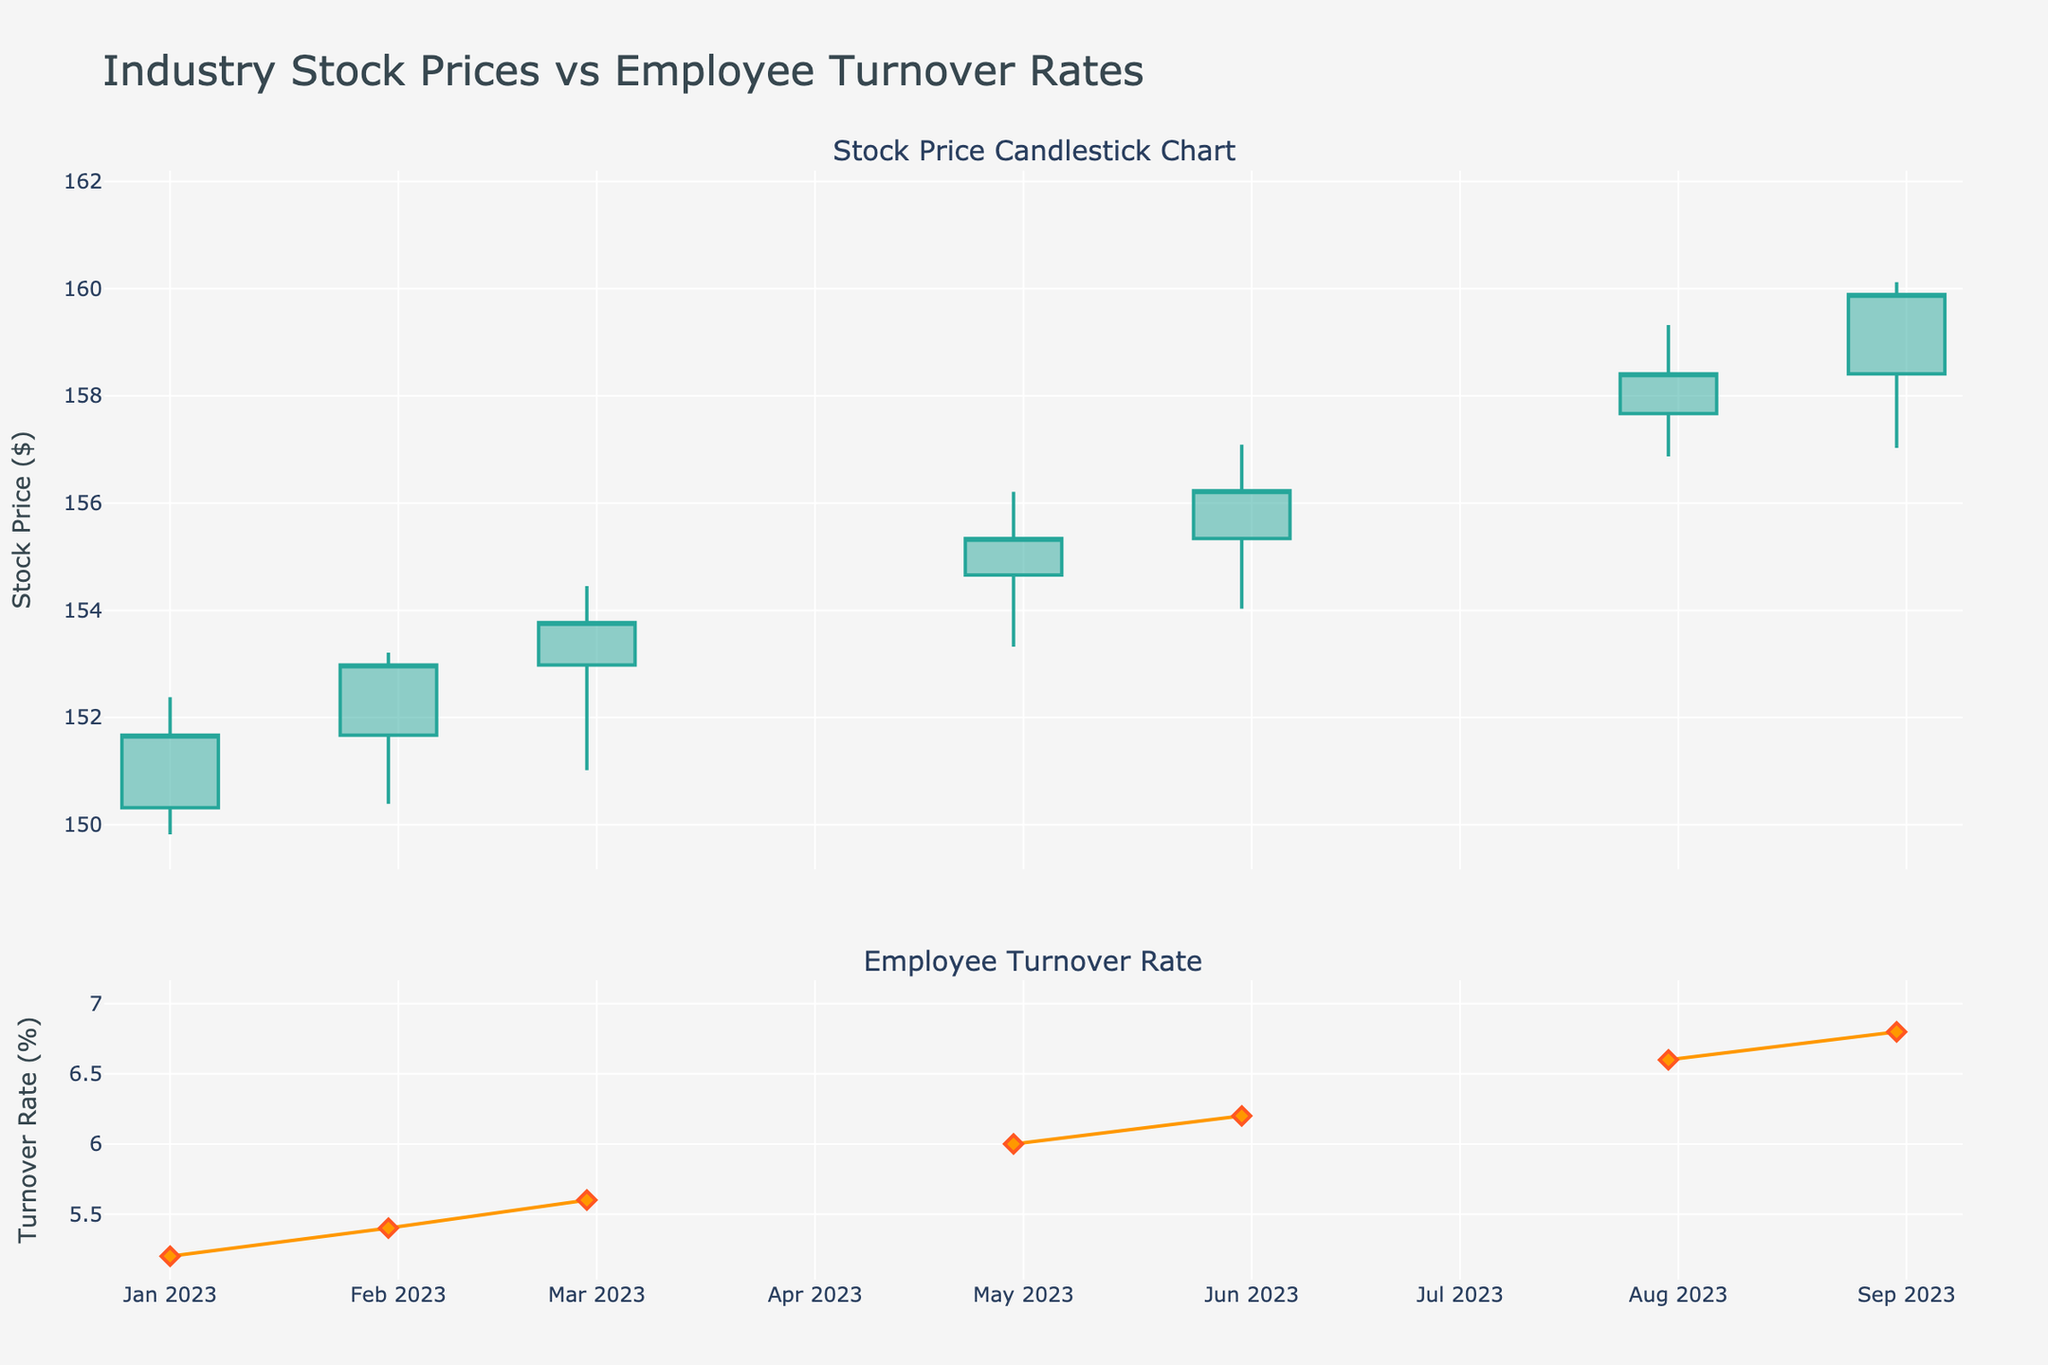What is the title of the figure? The title of the figure is prominently displayed at the top of the chart, showing the main topic of the visualization.
Answer: Industry Stock Prices vs Employee Turnover Rates How many data points are available for the Employee Turnover Rate? By counting the markers or data points on the Employee Turnover Rate line chart, we see that there is one data point for each month from January to October 2023, totaling 10 data points.
Answer: 10 What is the Employee Turnover Rate in March 2023? Locate the position on the x-axis corresponding to March 2023 and observe the y-axis value for the Employee Turnover Rate line. In March 2023, the rate is 5.6%.
Answer: 5.6% How did the stock price change from April 2023 to May 2023? Identify the candlestick for April and May, then compare their closing prices. April's closing price is 154.66, and May's closing price is 155.34, showing an increase.
Answer: Increased In which month did the stock price close at its highest value, and what was the Employee Turnover Rate in that month? Scan through the candlestick chart to find the highest closing price, then correlate this month with the Employee Turnover Rate chart. The highest closing price was in October 2023 at 160.27, with a turnover rate of 7.0%.
Answer: October 2023, 7.0% From January to March 2023, how much did the Employee Turnover Rate increase? Find the turnover rate for January (5.2%) and March (5.6%) and subtract the earlier value from the later one. The increase is 5.6% - 5.2% = 0.4%.
Answer: 0.4% What was the lowest stock price recorded, and in which month did it occur? Locate the line representing the lowest points on each candlestick and identify the minimum value. The lowest price was 149.82 in January 2023.
Answer: 149.82, January 2023 Which month had the greatest difference between the High and Low prices? For each month's candlestick, subtract the Low value from the High value and compare these differences. The greatest difference is in October 2023, where the High is 161.55 and the Low is 158.67, giving a difference of 2.88.
Answer: October 2023 Did the Employee Turnover Rate ever decrease during the months shown? Examine the Turnover Rate line plot and check if there is any downward movement month-to-month. There is no month where the Turnover Rate decreases; it only increases.
Answer: No 